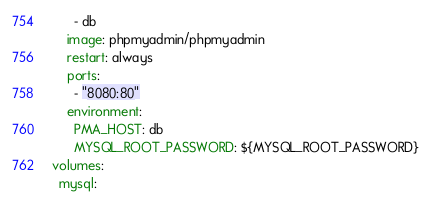Convert code to text. <code><loc_0><loc_0><loc_500><loc_500><_YAML_>      - db
    image: phpmyadmin/phpmyadmin
    restart: always
    ports:
      - "8080:80"
    environment:
      PMA_HOST: db
      MYSQL_ROOT_PASSWORD: ${MYSQL_ROOT_PASSWORD}
volumes:
  mysql:
</code> 